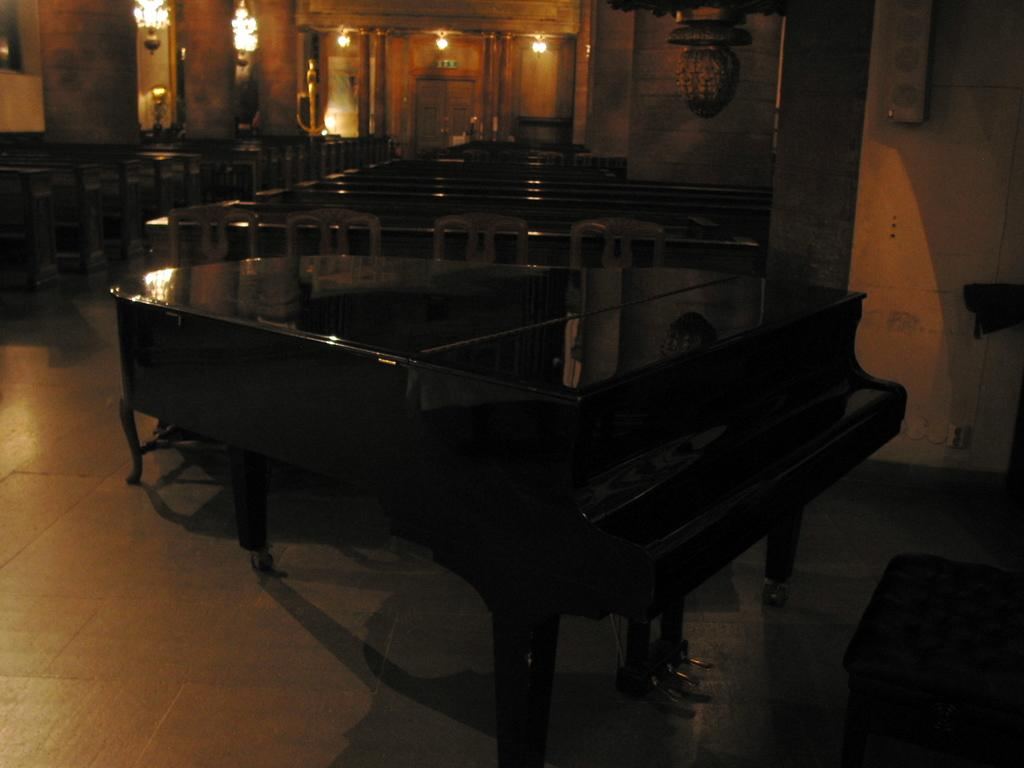What musical instrument is present in the image? There is a piano in the image. What type of seating is visible in the image? There are chairs and benches in the image. What can be seen providing illumination in the image? There are lights in the image. What type of whistle is being used to play the piano in the image? There is no whistle present in the image, and the piano is not being played with a whistle. What record is being played on the piano in the image? There is no record being played on the piano in the image; it is not an audio recording device. 